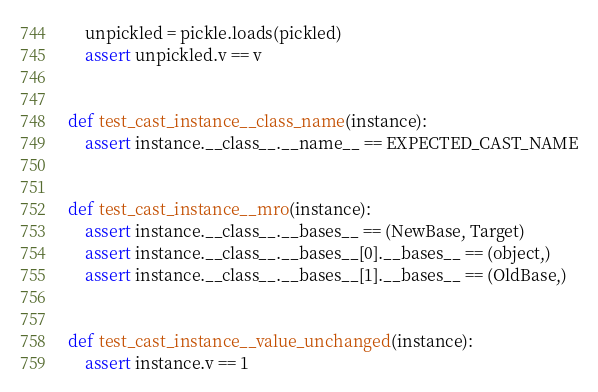Convert code to text. <code><loc_0><loc_0><loc_500><loc_500><_Python_>    unpickled = pickle.loads(pickled)
    assert unpickled.v == v


def test_cast_instance__class_name(instance):
    assert instance.__class__.__name__ == EXPECTED_CAST_NAME


def test_cast_instance__mro(instance):
    assert instance.__class__.__bases__ == (NewBase, Target)
    assert instance.__class__.__bases__[0].__bases__ == (object,)
    assert instance.__class__.__bases__[1].__bases__ == (OldBase,)


def test_cast_instance__value_unchanged(instance):
    assert instance.v == 1
</code> 